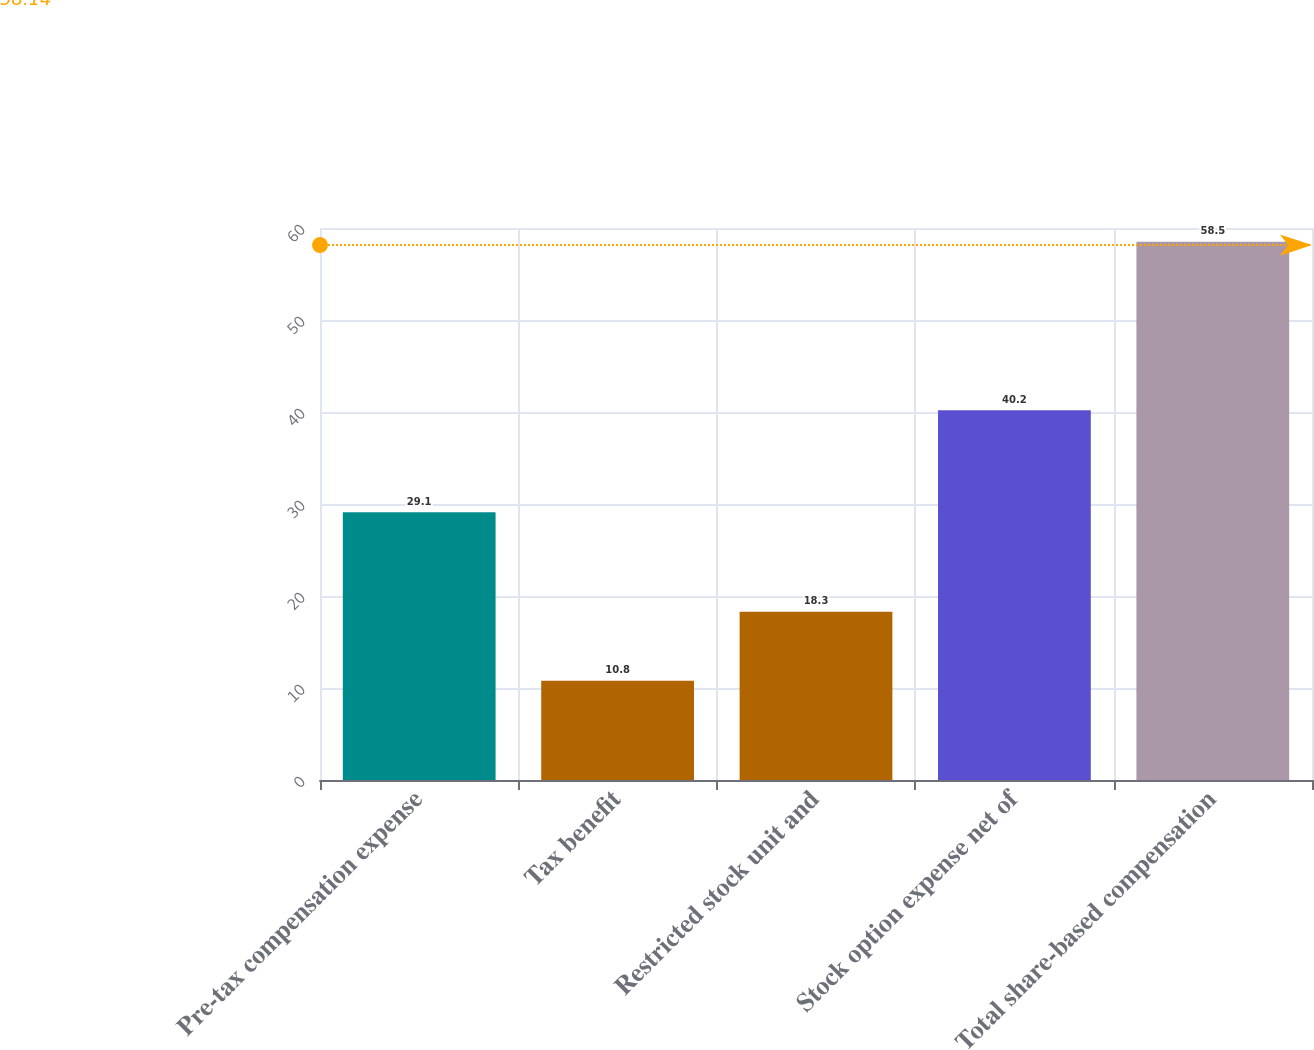Convert chart. <chart><loc_0><loc_0><loc_500><loc_500><bar_chart><fcel>Pre-tax compensation expense<fcel>Tax benefit<fcel>Restricted stock unit and<fcel>Stock option expense net of<fcel>Total share-based compensation<nl><fcel>29.1<fcel>10.8<fcel>18.3<fcel>40.2<fcel>58.5<nl></chart> 